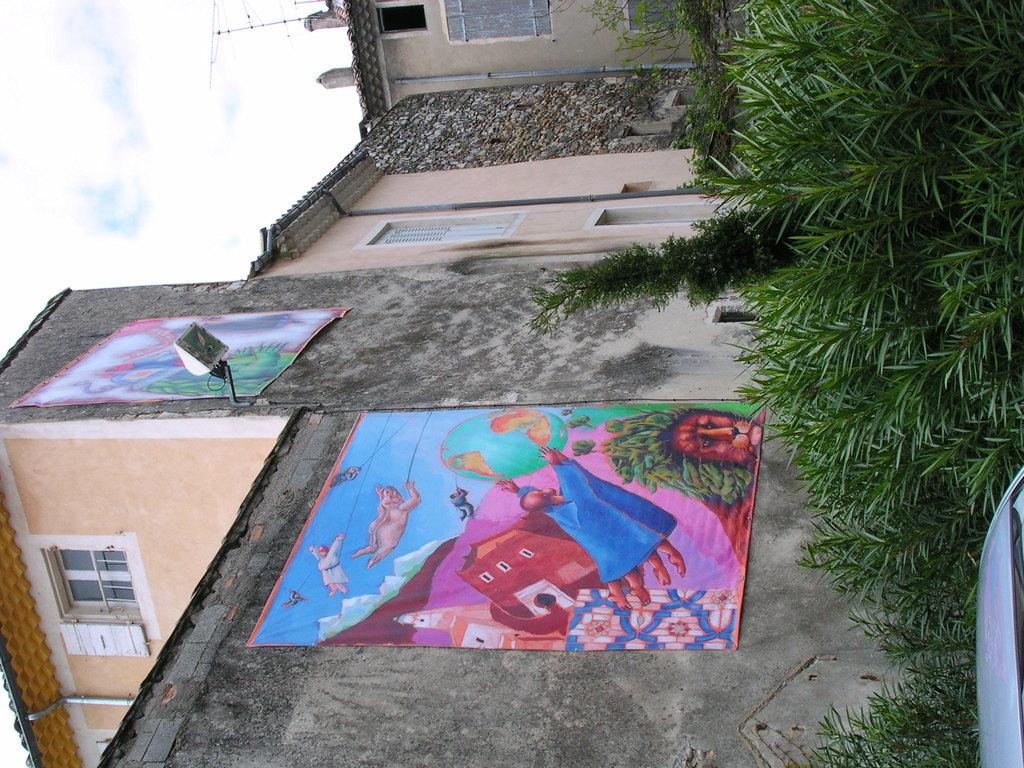What is the main subject of the image? There is a vehicle in the image. What type of environment is depicted in the image? There is grass, plants, and buildings visible in the image. Can you describe the lighting in the image? There is light visible in the image. What additional features can be seen on the buildings? There are banners on the building. What other objects can be seen in the image? There is an antenna in the image. What is visible in the background of the image? The sky is visible in the image. How many chickens are visible on the vehicle in the image? There are no chickens present on the vehicle or in the image. What type of business is being advertised on the banners? The image does not provide enough information to determine the type of business being advertised on the banners. 